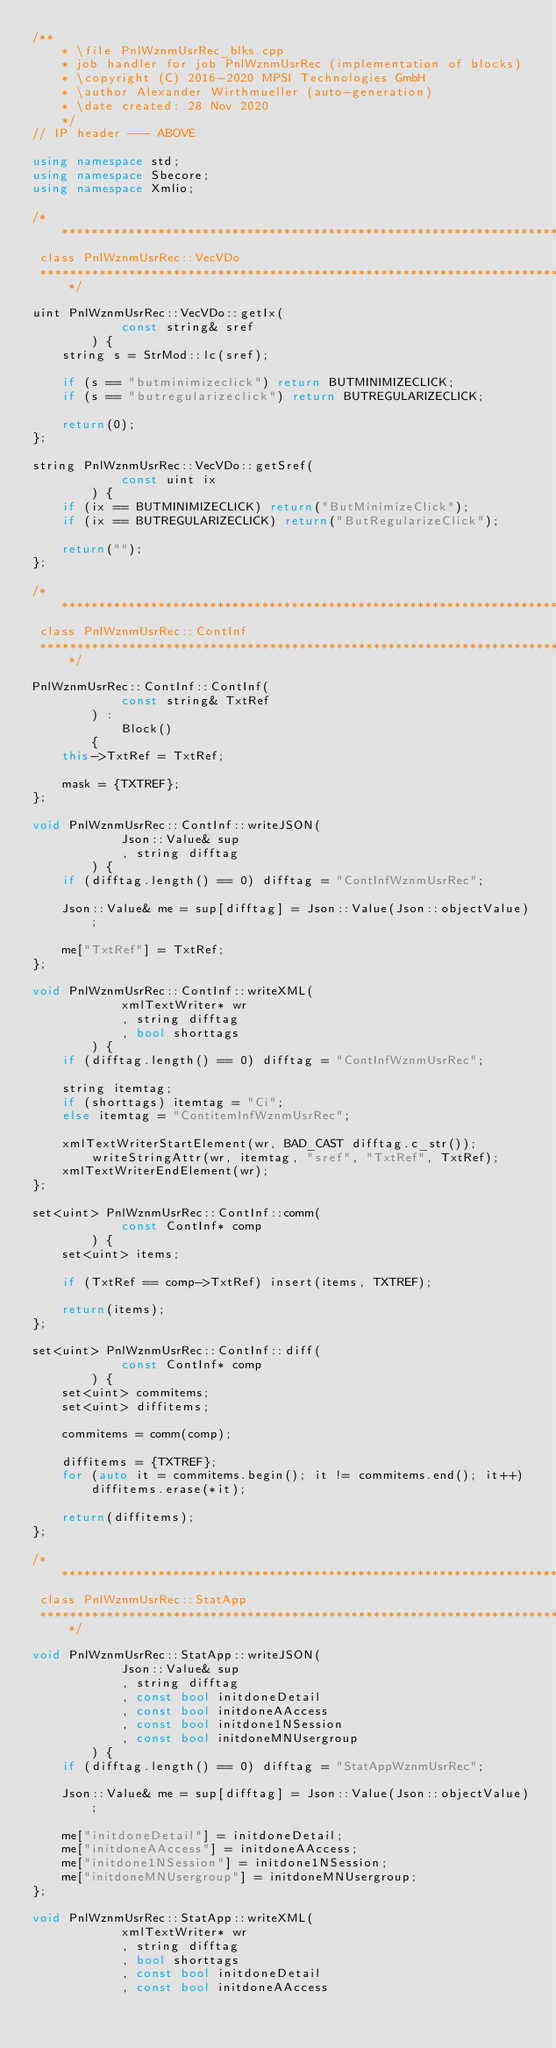<code> <loc_0><loc_0><loc_500><loc_500><_C++_>/**
	* \file PnlWznmUsrRec_blks.cpp
	* job handler for job PnlWznmUsrRec (implementation of blocks)
	* \copyright (C) 2016-2020 MPSI Technologies GmbH
	* \author Alexander Wirthmueller (auto-generation)
	* \date created: 28 Nov 2020
	*/
// IP header --- ABOVE

using namespace std;
using namespace Sbecore;
using namespace Xmlio;

/******************************************************************************
 class PnlWznmUsrRec::VecVDo
 ******************************************************************************/

uint PnlWznmUsrRec::VecVDo::getIx(
			const string& sref
		) {
	string s = StrMod::lc(sref);

	if (s == "butminimizeclick") return BUTMINIMIZECLICK;
	if (s == "butregularizeclick") return BUTREGULARIZECLICK;

	return(0);
};

string PnlWznmUsrRec::VecVDo::getSref(
			const uint ix
		) {
	if (ix == BUTMINIMIZECLICK) return("ButMinimizeClick");
	if (ix == BUTREGULARIZECLICK) return("ButRegularizeClick");

	return("");
};

/******************************************************************************
 class PnlWznmUsrRec::ContInf
 ******************************************************************************/

PnlWznmUsrRec::ContInf::ContInf(
			const string& TxtRef
		) :
			Block()
		{
	this->TxtRef = TxtRef;

	mask = {TXTREF};
};

void PnlWznmUsrRec::ContInf::writeJSON(
			Json::Value& sup
			, string difftag
		) {
	if (difftag.length() == 0) difftag = "ContInfWznmUsrRec";

	Json::Value& me = sup[difftag] = Json::Value(Json::objectValue);

	me["TxtRef"] = TxtRef;
};

void PnlWznmUsrRec::ContInf::writeXML(
			xmlTextWriter* wr
			, string difftag
			, bool shorttags
		) {
	if (difftag.length() == 0) difftag = "ContInfWznmUsrRec";

	string itemtag;
	if (shorttags) itemtag = "Ci";
	else itemtag = "ContitemInfWznmUsrRec";

	xmlTextWriterStartElement(wr, BAD_CAST difftag.c_str());
		writeStringAttr(wr, itemtag, "sref", "TxtRef", TxtRef);
	xmlTextWriterEndElement(wr);
};

set<uint> PnlWznmUsrRec::ContInf::comm(
			const ContInf* comp
		) {
	set<uint> items;

	if (TxtRef == comp->TxtRef) insert(items, TXTREF);

	return(items);
};

set<uint> PnlWznmUsrRec::ContInf::diff(
			const ContInf* comp
		) {
	set<uint> commitems;
	set<uint> diffitems;

	commitems = comm(comp);

	diffitems = {TXTREF};
	for (auto it = commitems.begin(); it != commitems.end(); it++) diffitems.erase(*it);

	return(diffitems);
};

/******************************************************************************
 class PnlWznmUsrRec::StatApp
 ******************************************************************************/

void PnlWznmUsrRec::StatApp::writeJSON(
			Json::Value& sup
			, string difftag
			, const bool initdoneDetail
			, const bool initdoneAAccess
			, const bool initdone1NSession
			, const bool initdoneMNUsergroup
		) {
	if (difftag.length() == 0) difftag = "StatAppWznmUsrRec";

	Json::Value& me = sup[difftag] = Json::Value(Json::objectValue);

	me["initdoneDetail"] = initdoneDetail;
	me["initdoneAAccess"] = initdoneAAccess;
	me["initdone1NSession"] = initdone1NSession;
	me["initdoneMNUsergroup"] = initdoneMNUsergroup;
};

void PnlWznmUsrRec::StatApp::writeXML(
			xmlTextWriter* wr
			, string difftag
			, bool shorttags
			, const bool initdoneDetail
			, const bool initdoneAAccess</code> 